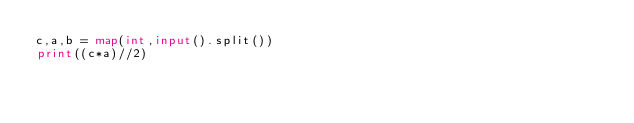Convert code to text. <code><loc_0><loc_0><loc_500><loc_500><_Python_>c,a,b = map(int,input().split())
print((c*a)//2)</code> 